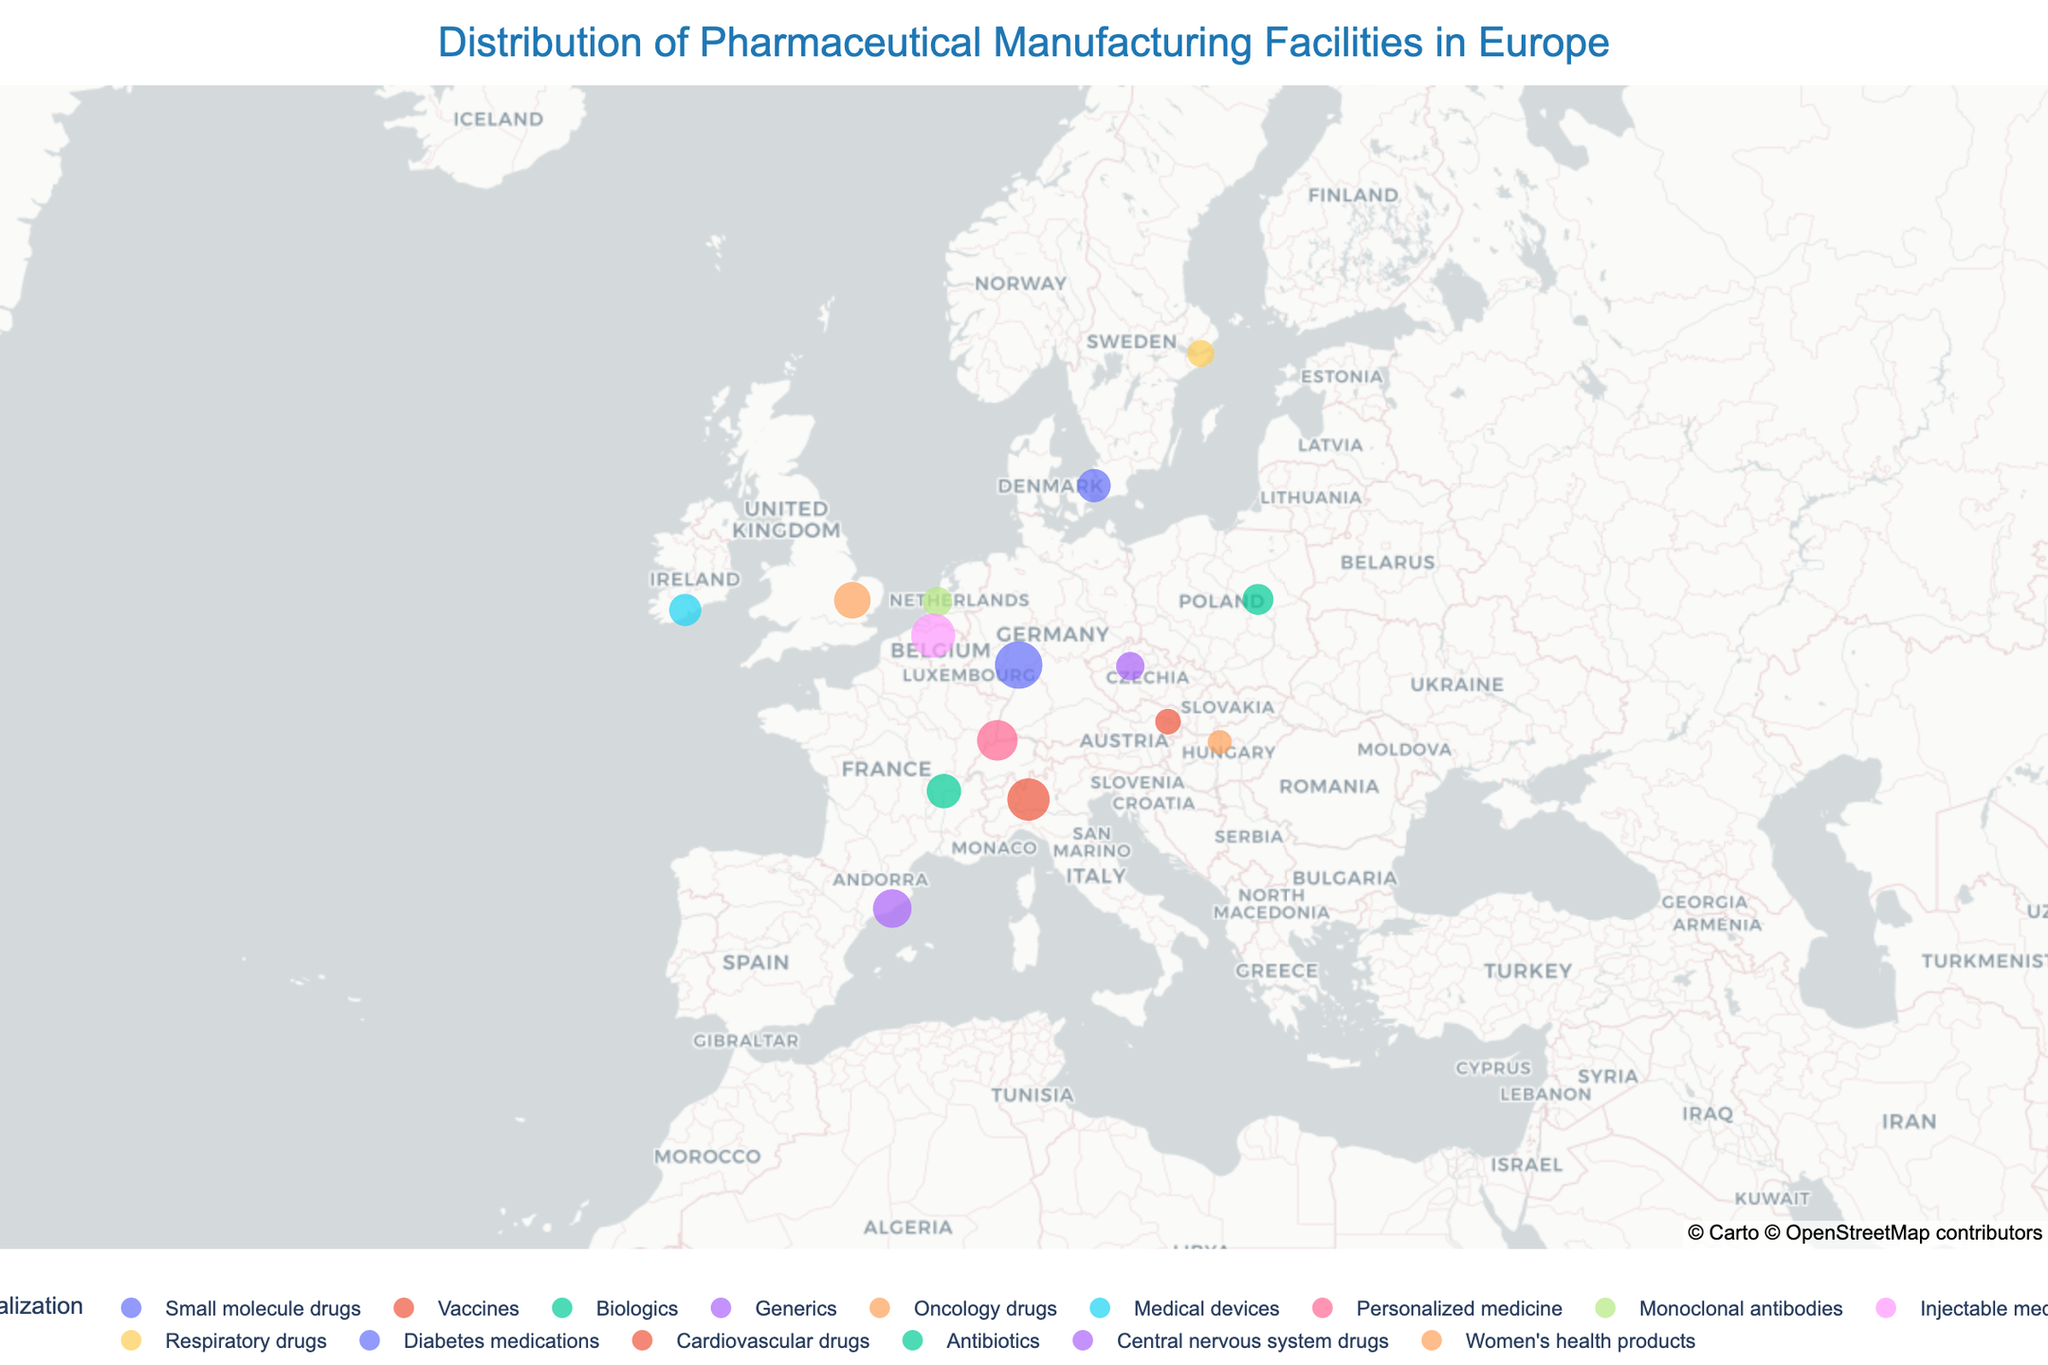What is the title of the plot? The title is placed at the top of the plot and provides an overview of what the plot is illustrating. You can find it centered above the map.
Answer: Distribution of Pharmaceutical Manufacturing Facilities in Europe How many countries have pharmaceutical manufacturing facilities on this map? To determine the number of countries, look at the different countries listed in the hover information or legend next to each data point. Count the distinct country names.
Answer: 14 Which city has the largest pharmaceutical manufacturing facility in terms of capacity? By looking at the size of the circles representing the facilities, you can identify the largest one. Hover over the circles to see the capacity details. The largest capacity is 15000 tons/year, which is in Frankfurt, Germany.
Answer: Frankfurt What is the specialization of the facility in Basel, Switzerland? Hover over the data point in Basel, Switzerland to see the facility's specialization.
Answer: Personalized medicine Which specialization appears most frequently on the map? Check the legend to see all specializations and see which color representing a specialization appears most frequently within the map.
Answer: Each specialization appears only once What is the combined manufacturing capacity of the facilities in Germany, Italy, and France? First, locate the facilities in Germany, Italy, and France. Then, sum their capacities: 15000 (Germany) + 12000 (Italy) + 8000 (France).
Answer: 35000 tons/year Which country has the lowest manufacturing capacity, according to the map? Compare the 'size' (capacity) of the facilities by looking at the size of each circle. Hovering over each circle will give you the exact capacity. The smallest capacity on the map is for Hungary with 4000 tons/year.
Answer: Hungary How many facilities specialize in biologics? Identify the color that represents 'Biologics' from the legend. Count the number of circles in the plot that match this color.
Answer: 2 Which two facilities have a similar manufacturing capacity of around 7000 tons/year and what are their specializations? Look for data points with similar-sized circles representing around 7000 tons/year. Hover over these points to identify their locations and specializations.
Answer: Ireland (Medical devices) and Denmark (Diabetes medications) What is the specialization of the facility with the second-highest capacity? Hover over the different data points to see the capacities. The second-highest capacity is 13000 tons/year located in Puurs, Belgium. Check its specialization.
Answer: Injectable medicines 